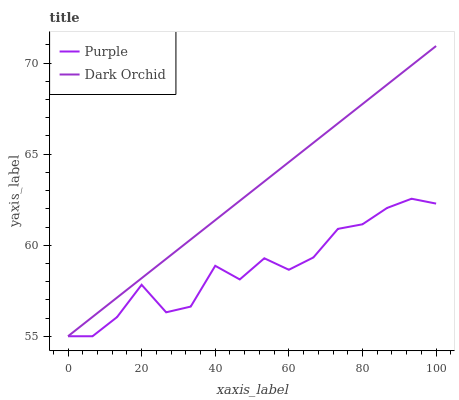Does Purple have the minimum area under the curve?
Answer yes or no. Yes. Does Dark Orchid have the maximum area under the curve?
Answer yes or no. Yes. Does Dark Orchid have the minimum area under the curve?
Answer yes or no. No. Is Dark Orchid the smoothest?
Answer yes or no. Yes. Is Purple the roughest?
Answer yes or no. Yes. Is Dark Orchid the roughest?
Answer yes or no. No. Does Purple have the lowest value?
Answer yes or no. Yes. Does Dark Orchid have the highest value?
Answer yes or no. Yes. Does Dark Orchid intersect Purple?
Answer yes or no. Yes. Is Dark Orchid less than Purple?
Answer yes or no. No. Is Dark Orchid greater than Purple?
Answer yes or no. No. 